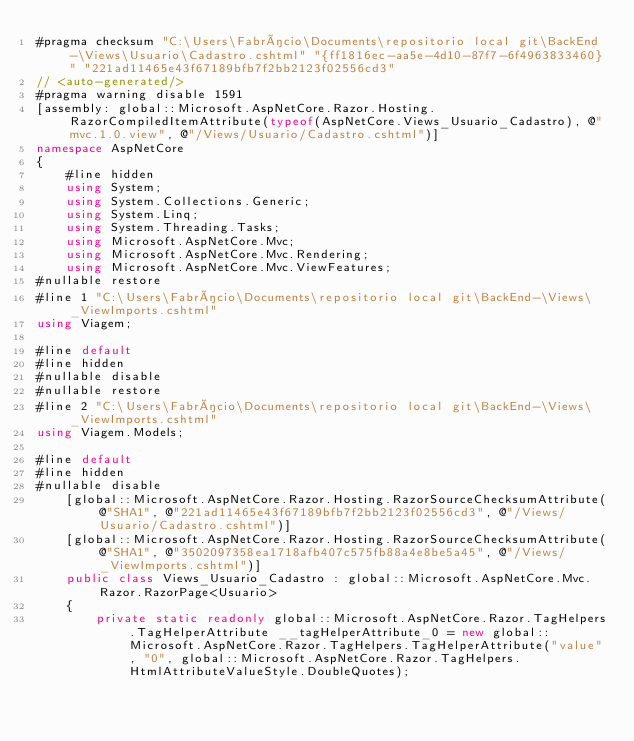<code> <loc_0><loc_0><loc_500><loc_500><_C#_>#pragma checksum "C:\Users\Fabrício\Documents\repositorio local git\BackEnd-\Views\Usuario\Cadastro.cshtml" "{ff1816ec-aa5e-4d10-87f7-6f4963833460}" "221ad11465e43f67189bfb7f2bb2123f02556cd3"
// <auto-generated/>
#pragma warning disable 1591
[assembly: global::Microsoft.AspNetCore.Razor.Hosting.RazorCompiledItemAttribute(typeof(AspNetCore.Views_Usuario_Cadastro), @"mvc.1.0.view", @"/Views/Usuario/Cadastro.cshtml")]
namespace AspNetCore
{
    #line hidden
    using System;
    using System.Collections.Generic;
    using System.Linq;
    using System.Threading.Tasks;
    using Microsoft.AspNetCore.Mvc;
    using Microsoft.AspNetCore.Mvc.Rendering;
    using Microsoft.AspNetCore.Mvc.ViewFeatures;
#nullable restore
#line 1 "C:\Users\Fabrício\Documents\repositorio local git\BackEnd-\Views\_ViewImports.cshtml"
using Viagem;

#line default
#line hidden
#nullable disable
#nullable restore
#line 2 "C:\Users\Fabrício\Documents\repositorio local git\BackEnd-\Views\_ViewImports.cshtml"
using Viagem.Models;

#line default
#line hidden
#nullable disable
    [global::Microsoft.AspNetCore.Razor.Hosting.RazorSourceChecksumAttribute(@"SHA1", @"221ad11465e43f67189bfb7f2bb2123f02556cd3", @"/Views/Usuario/Cadastro.cshtml")]
    [global::Microsoft.AspNetCore.Razor.Hosting.RazorSourceChecksumAttribute(@"SHA1", @"3502097358ea1718afb407c575fb88a4e8be5a45", @"/Views/_ViewImports.cshtml")]
    public class Views_Usuario_Cadastro : global::Microsoft.AspNetCore.Mvc.Razor.RazorPage<Usuario>
    {
        private static readonly global::Microsoft.AspNetCore.Razor.TagHelpers.TagHelperAttribute __tagHelperAttribute_0 = new global::Microsoft.AspNetCore.Razor.TagHelpers.TagHelperAttribute("value", "0", global::Microsoft.AspNetCore.Razor.TagHelpers.HtmlAttributeValueStyle.DoubleQuotes);</code> 